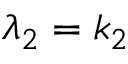<formula> <loc_0><loc_0><loc_500><loc_500>\lambda _ { 2 } = k _ { 2 }</formula> 